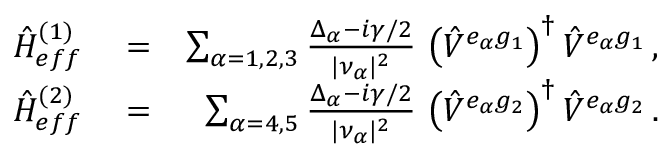Convert formula to latex. <formula><loc_0><loc_0><loc_500><loc_500>\begin{array} { r l r } { { \hat { H } } _ { e f f } ^ { ( 1 ) } } & = } & { \sum _ { \alpha = 1 , 2 , 3 } \frac { \Delta _ { \alpha } - i \gamma / 2 } { | \nu _ { \alpha } | ^ { 2 } } \, \left ( { \hat { V } } ^ { e _ { \alpha } g _ { 1 } } \right ) ^ { \dagger } { \hat { V } } ^ { e _ { \alpha } g _ { 1 } } \, , } \\ { { \hat { H } } _ { e f f } ^ { ( 2 ) } } & = } & { \sum _ { \alpha = 4 , 5 } \frac { \Delta _ { \alpha } - i \gamma / 2 } { | \nu _ { \alpha } | ^ { 2 } } \, \left ( { \hat { V } } ^ { e _ { \alpha } g _ { 2 } } \right ) ^ { \dagger } { \hat { V } } ^ { e _ { \alpha } g _ { 2 } } \, . } \end{array}</formula> 